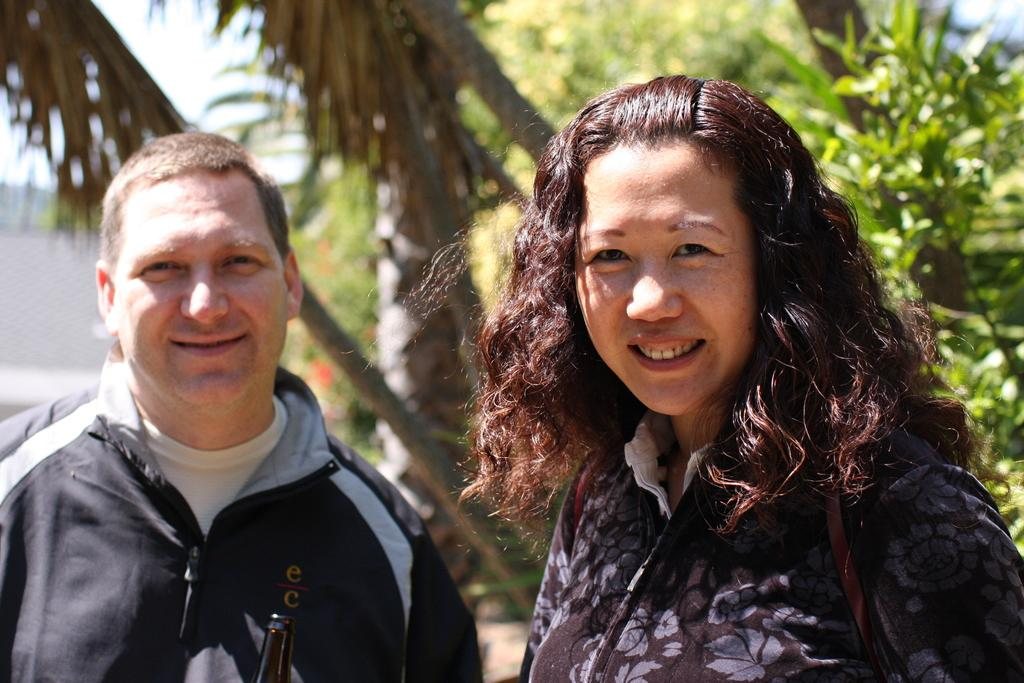How many people are present in the image? There is a man and a woman present in the image. What is located at the bottom of the image? There is a bottle at the bottom of the image. What can be seen in the background of the image? Trees, sky, and an unspecified object can be seen in the background of the image. What type of jelly can be seen on the trees in the background? There is no jelly present on the trees in the background; only trees and sky are visible. How does the man in the image show care for the woman? The image does not provide information about the relationship between the man and the woman or any actions that might indicate care. 